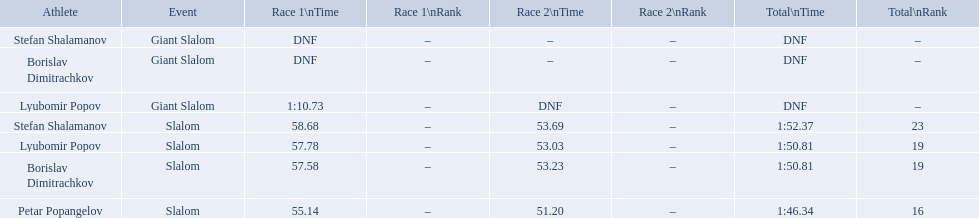What are all the competitions lyubomir popov competed in? Lyubomir Popov, Lyubomir Popov. Of those, which were giant slalom races? Giant Slalom. What was his time in race 1? 1:10.73. 